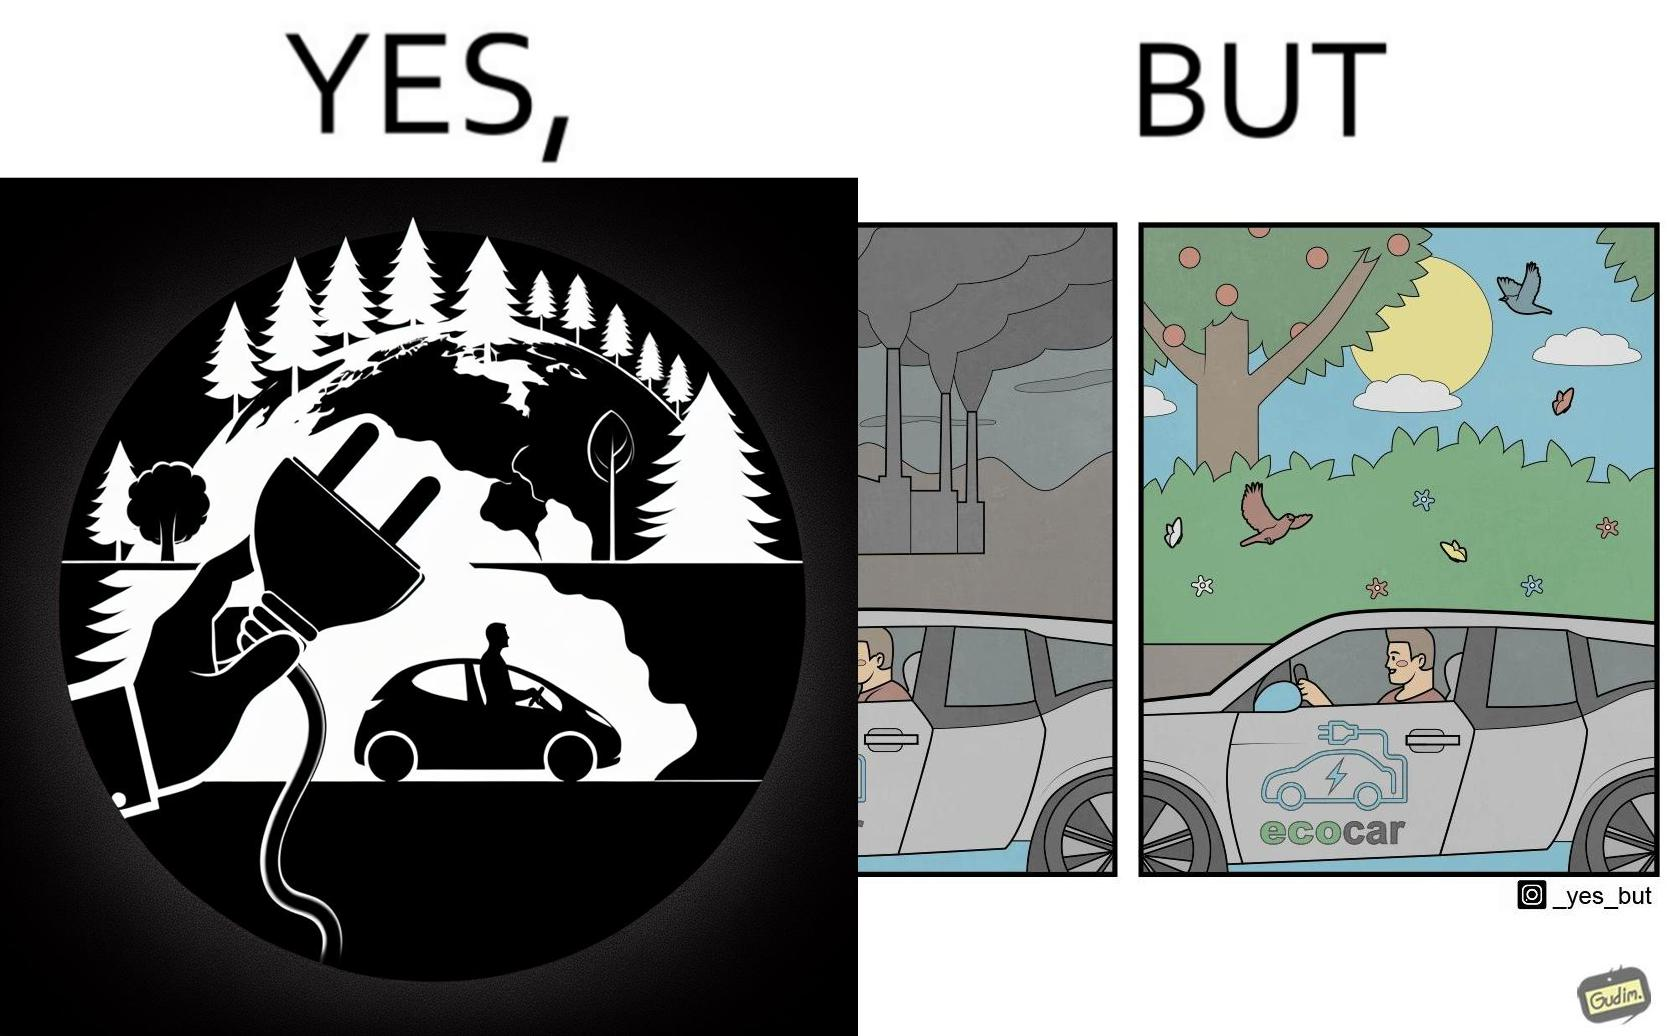Is there satirical content in this image? Yes, this image is satirical. 